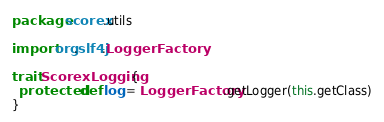<code> <loc_0><loc_0><loc_500><loc_500><_Scala_>package scorex.utils

import org.slf4j.LoggerFactory

trait ScorexLogging {
  protected def log = LoggerFactory.getLogger(this.getClass)
}
</code> 